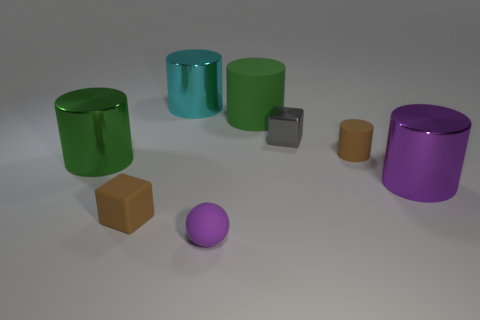There is a brown block to the left of the big metallic object behind the tiny brown matte cylinder; how big is it?
Provide a short and direct response. Small. How many large green shiny things are the same shape as the large cyan object?
Provide a short and direct response. 1. Do the matte ball and the tiny metallic thing have the same color?
Make the answer very short. No. Is there any other thing that has the same shape as the big purple shiny object?
Make the answer very short. Yes. Is there a metallic cylinder that has the same color as the metal cube?
Offer a terse response. No. Does the tiny cube that is to the left of the cyan cylinder have the same material as the brown object that is behind the big green shiny thing?
Give a very brief answer. Yes. What color is the matte ball?
Your answer should be compact. Purple. How big is the brown rubber thing left of the metallic object behind the green cylinder on the right side of the big cyan shiny cylinder?
Ensure brevity in your answer.  Small. What number of other objects are there of the same size as the cyan thing?
Ensure brevity in your answer.  3. What number of big green cylinders have the same material as the small gray cube?
Keep it short and to the point. 1. 